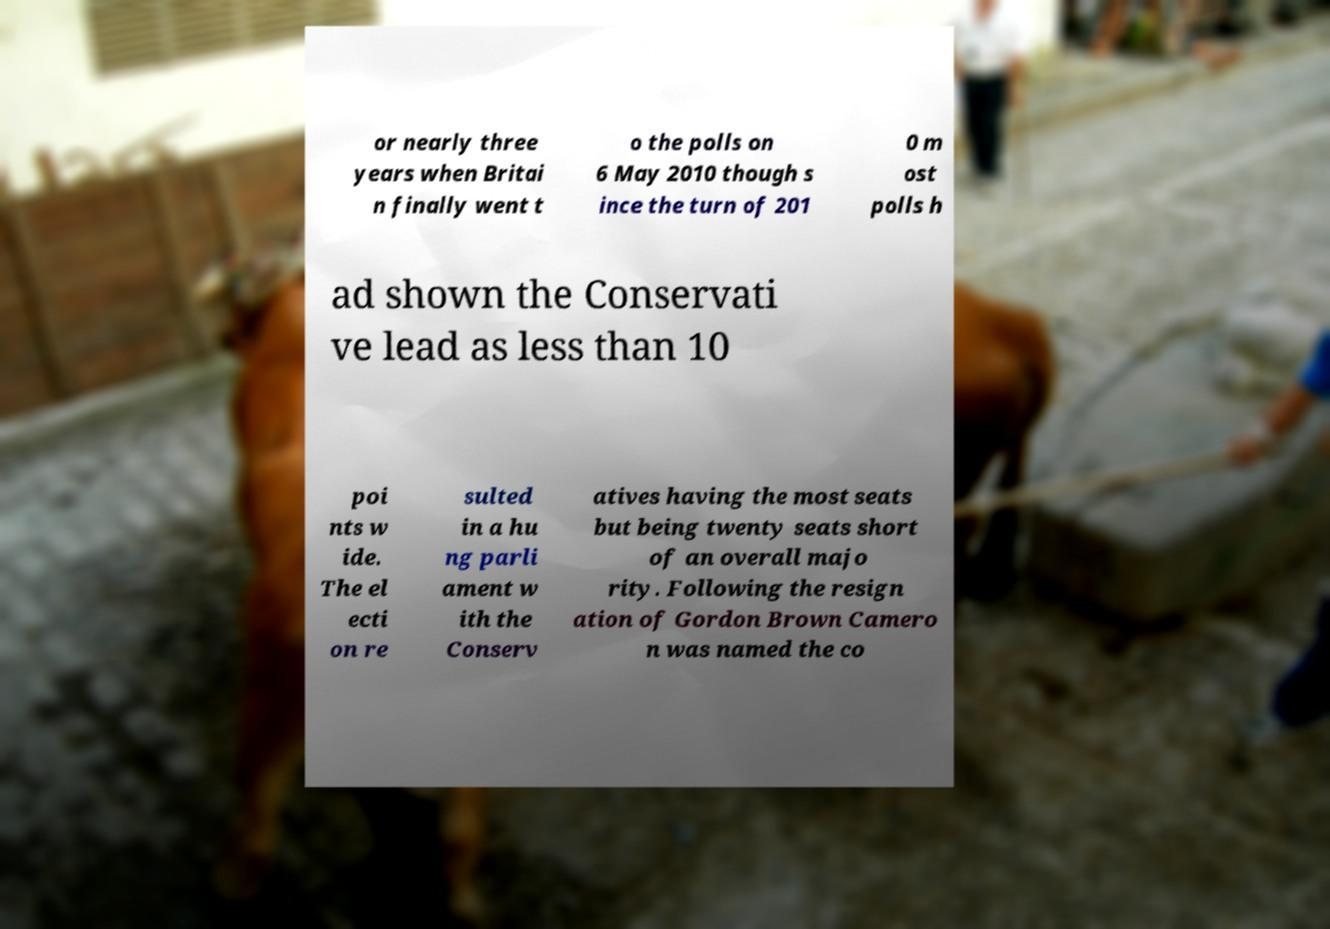Please identify and transcribe the text found in this image. or nearly three years when Britai n finally went t o the polls on 6 May 2010 though s ince the turn of 201 0 m ost polls h ad shown the Conservati ve lead as less than 10 poi nts w ide. The el ecti on re sulted in a hu ng parli ament w ith the Conserv atives having the most seats but being twenty seats short of an overall majo rity. Following the resign ation of Gordon Brown Camero n was named the co 